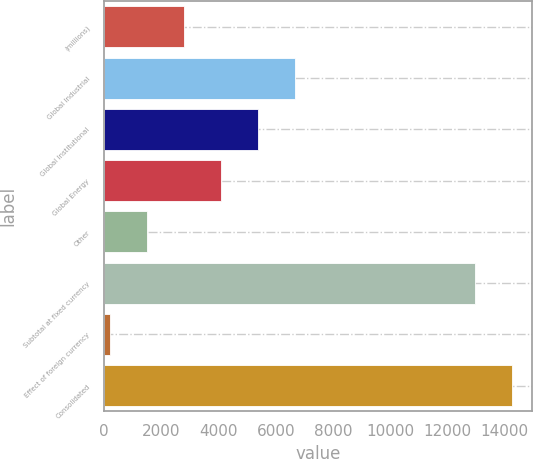<chart> <loc_0><loc_0><loc_500><loc_500><bar_chart><fcel>(millions)<fcel>Global Industrial<fcel>Global Institutional<fcel>Global Energy<fcel>Other<fcel>Subtotal at fixed currency<fcel>Effect of foreign currency<fcel>Consolidated<nl><fcel>2788.8<fcel>6675.3<fcel>5379.8<fcel>4084.3<fcel>1493.3<fcel>12955<fcel>197.8<fcel>14250.5<nl></chart> 